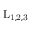<formula> <loc_0><loc_0><loc_500><loc_500>L _ { 1 , 2 , 3 }</formula> 